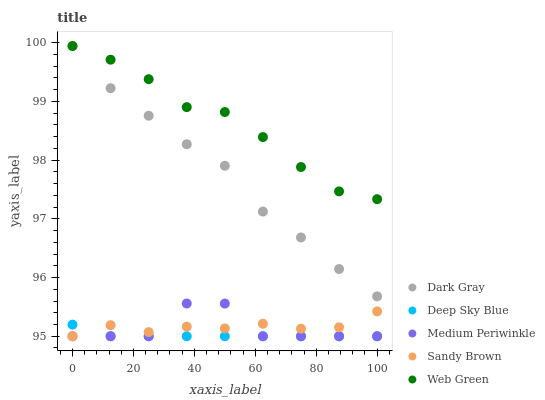Does Deep Sky Blue have the minimum area under the curve?
Answer yes or no. Yes. Does Web Green have the maximum area under the curve?
Answer yes or no. Yes. Does Sandy Brown have the minimum area under the curve?
Answer yes or no. No. Does Sandy Brown have the maximum area under the curve?
Answer yes or no. No. Is Deep Sky Blue the smoothest?
Answer yes or no. Yes. Is Medium Periwinkle the roughest?
Answer yes or no. Yes. Is Sandy Brown the smoothest?
Answer yes or no. No. Is Sandy Brown the roughest?
Answer yes or no. No. Does Sandy Brown have the lowest value?
Answer yes or no. Yes. Does Web Green have the lowest value?
Answer yes or no. No. Does Dark Gray have the highest value?
Answer yes or no. Yes. Does Sandy Brown have the highest value?
Answer yes or no. No. Is Medium Periwinkle less than Dark Gray?
Answer yes or no. Yes. Is Dark Gray greater than Medium Periwinkle?
Answer yes or no. Yes. Does Deep Sky Blue intersect Medium Periwinkle?
Answer yes or no. Yes. Is Deep Sky Blue less than Medium Periwinkle?
Answer yes or no. No. Is Deep Sky Blue greater than Medium Periwinkle?
Answer yes or no. No. Does Medium Periwinkle intersect Dark Gray?
Answer yes or no. No. 